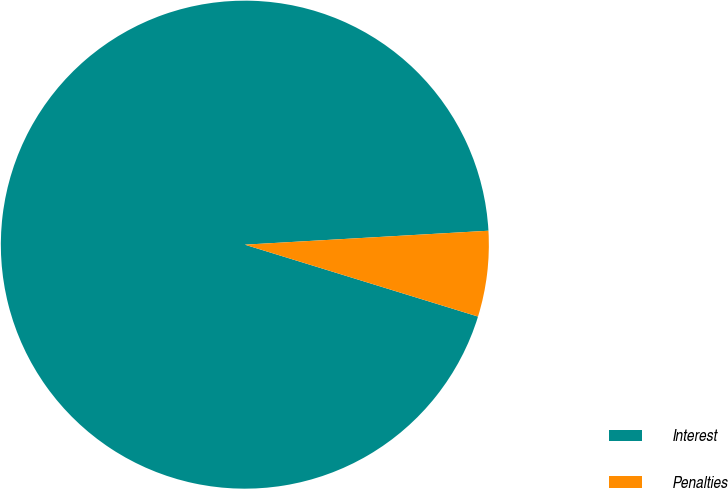<chart> <loc_0><loc_0><loc_500><loc_500><pie_chart><fcel>Interest<fcel>Penalties<nl><fcel>94.33%<fcel>5.67%<nl></chart> 